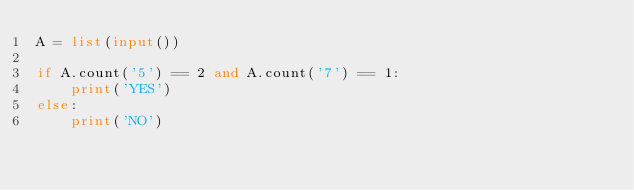Convert code to text. <code><loc_0><loc_0><loc_500><loc_500><_Python_>A = list(input())

if A.count('5') == 2 and A.count('7') == 1:
    print('YES')
else:
    print('NO')</code> 